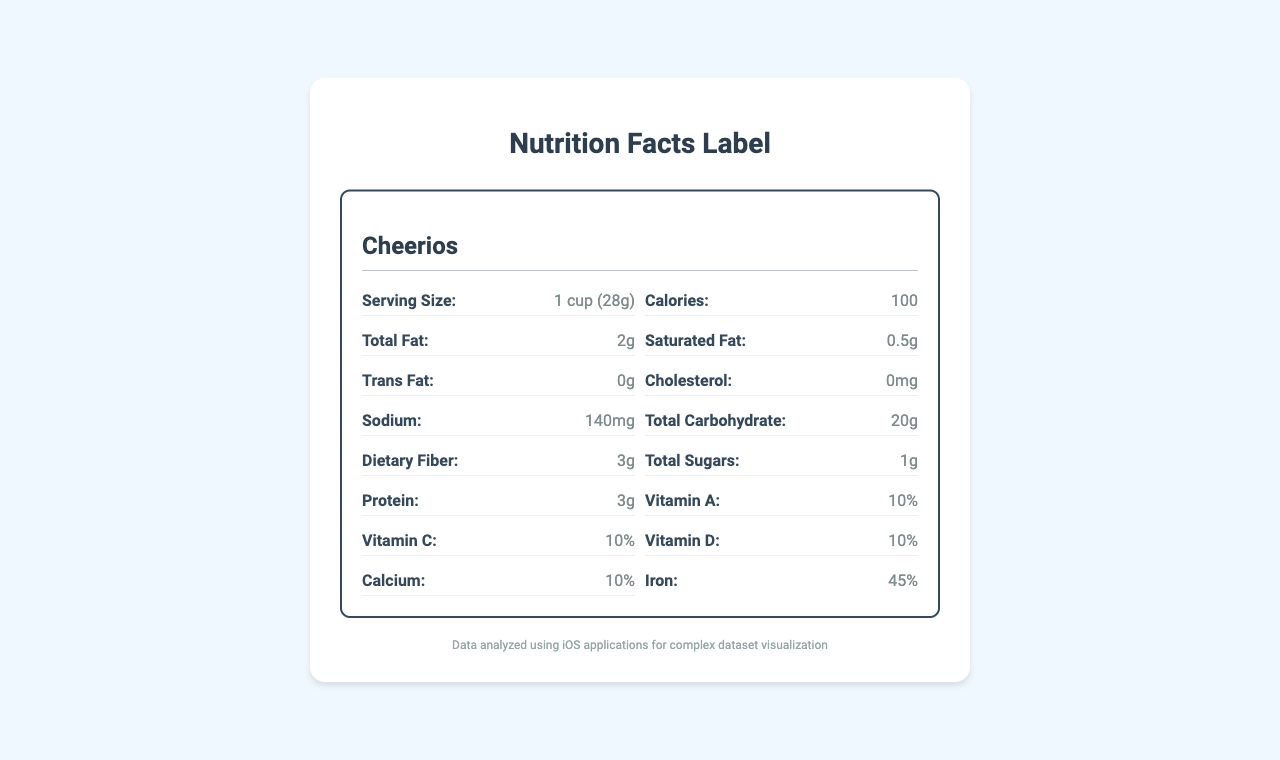What is the serving size of Cheerios? The serving size of Cheerios is listed at the top of the Cheerios section in the document.
Answer: 1 cup (28g) How many calories are there in a serving of Raisin Bran? The calorie count for Raisin Bran is written in the Raisin Bran section in the document.
Answer: 190 What is the percentage of the daily value of iron in Frosted Flakes? The document lists the iron content of Frosted Flakes as 25% daily value.
Answer: 25% Which cereal has the highest dietary fiber content? Raisin Bran contains 7g of dietary fiber, which is higher than the other cereals listed.
Answer: Raisin Bran How many grams of total sugars does a serving of Frosted Flakes contain? Frosted Flakes has 12g of total sugars per serving as mentioned in its section.
Answer: 12g Which cereal has the least amount of sodium? A. Cheerios B. Frosted Flakes C. Raisin Bran Cheerios has 140mg of sodium, which is less than the 150mg in Frosted Flakes and 210mg in Raisin Bran.
Answer: A. Cheerios Among the listed cereals, which one has the highest protein content? A. Cheerios B. Frosted Flakes C. Raisin Bran Raisin Bran contains 5g of protein, while Cheerios contains 3g and Frosted Flakes contains 1g.
Answer: C. Raisin Bran Does Cheerios contain any trans fats? The document states that Cheerios contains 0 grams of trans fats.
Answer: No Summarize the main purpose of the document. The document's purpose is to present a comparative analysis of nutritional content across three cereals, aiding consumers in making informed dietary choices based on nutritional value.
Answer: The document compares the nutrition facts of three popular breakfast cereals: Cheerios, Frosted Flakes, and Raisin Bran. It provides detailed information on serving size, calorie count, and various nutritional components such as fats, carbohydrates, and different vitamins and minerals. What are the key nutritional considerations mentioned in the document? The document lists specific nutritional values for cereals but does not explicitly mention the key nutritional considerations section. Therefore, the exact key nutritional considerations can't be determined from the visual content alone.
Answer: Cannot be determined 